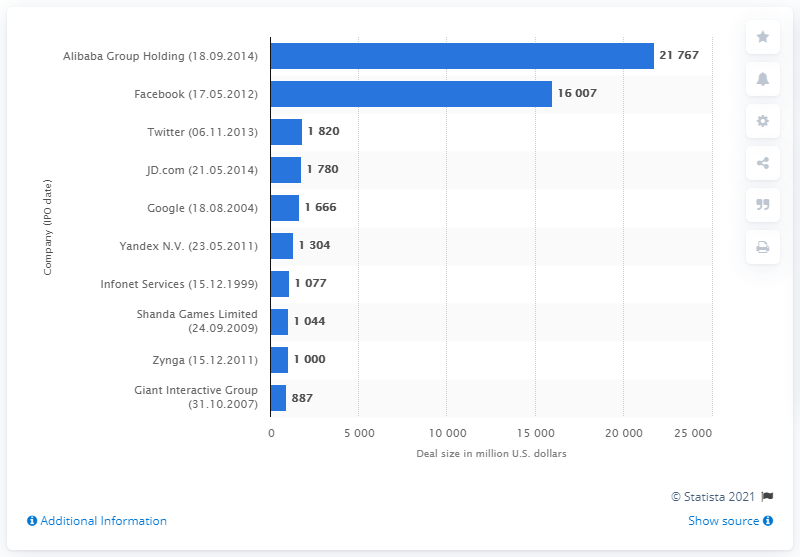Identify some key points in this picture. The initial public offering (IPO) of Facebook raised 16007. 